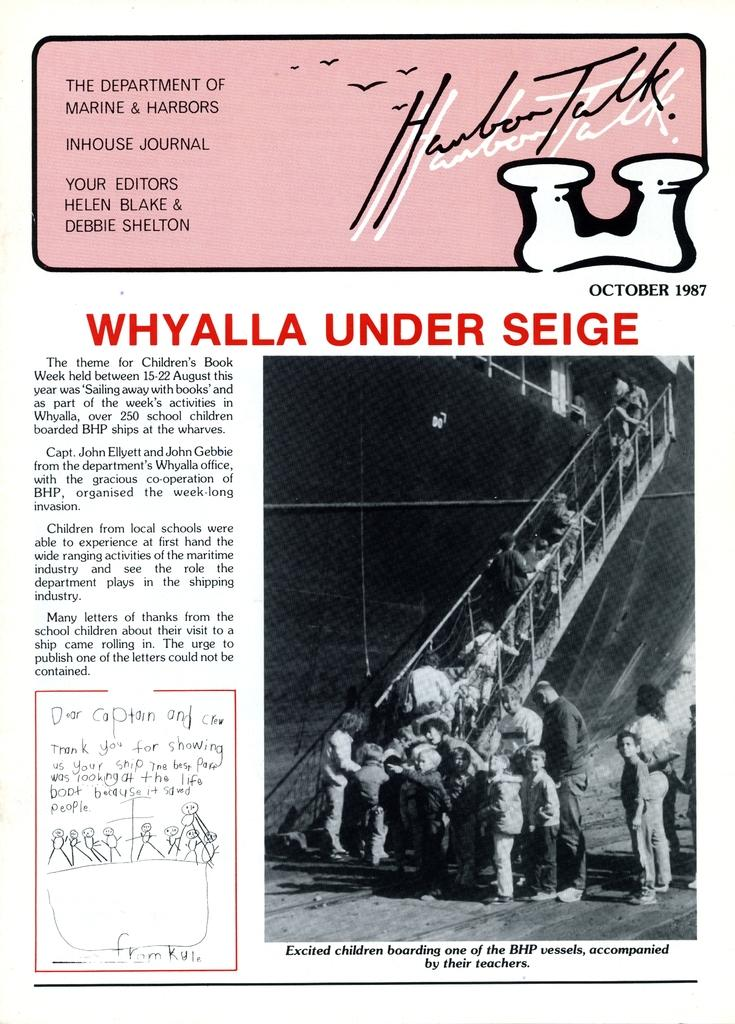<image>
Present a compact description of the photo's key features. The Department of Marine & Harbors Inhouse Journal discussing a recents children's trip to a large sea vessel. 